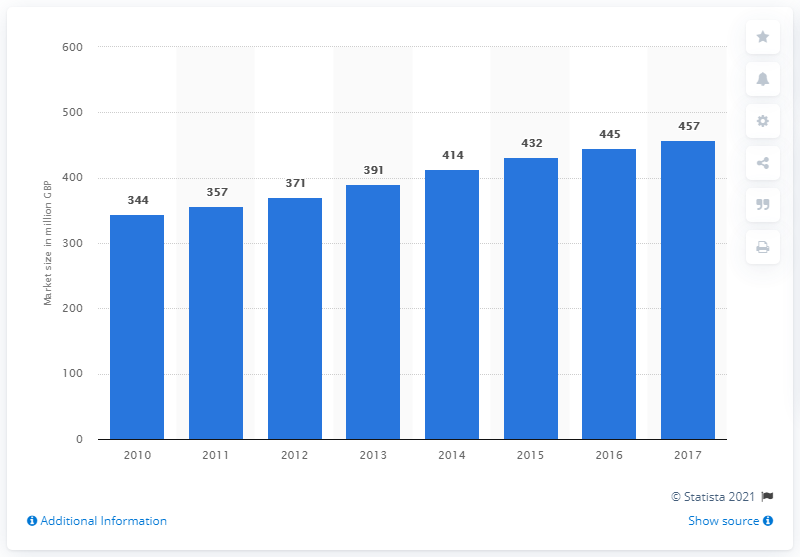Point out several critical features in this image. The software solution segment began to grow in the UK in the year 2010. In 2017, the estimated size of the software solution segment was approximately 457. 